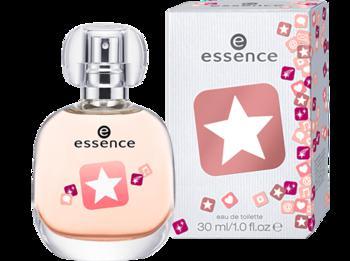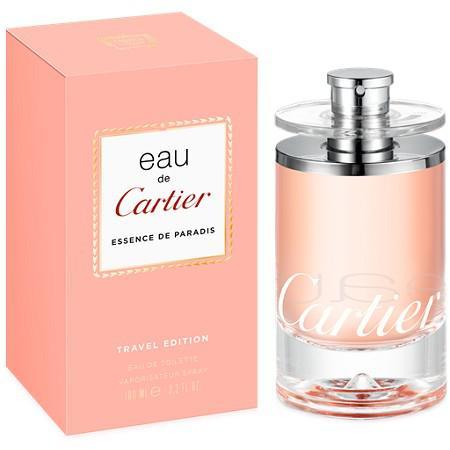The first image is the image on the left, the second image is the image on the right. For the images shown, is this caption "one of the perfume bottles has a ribbon on its neck." true? Answer yes or no. No. 